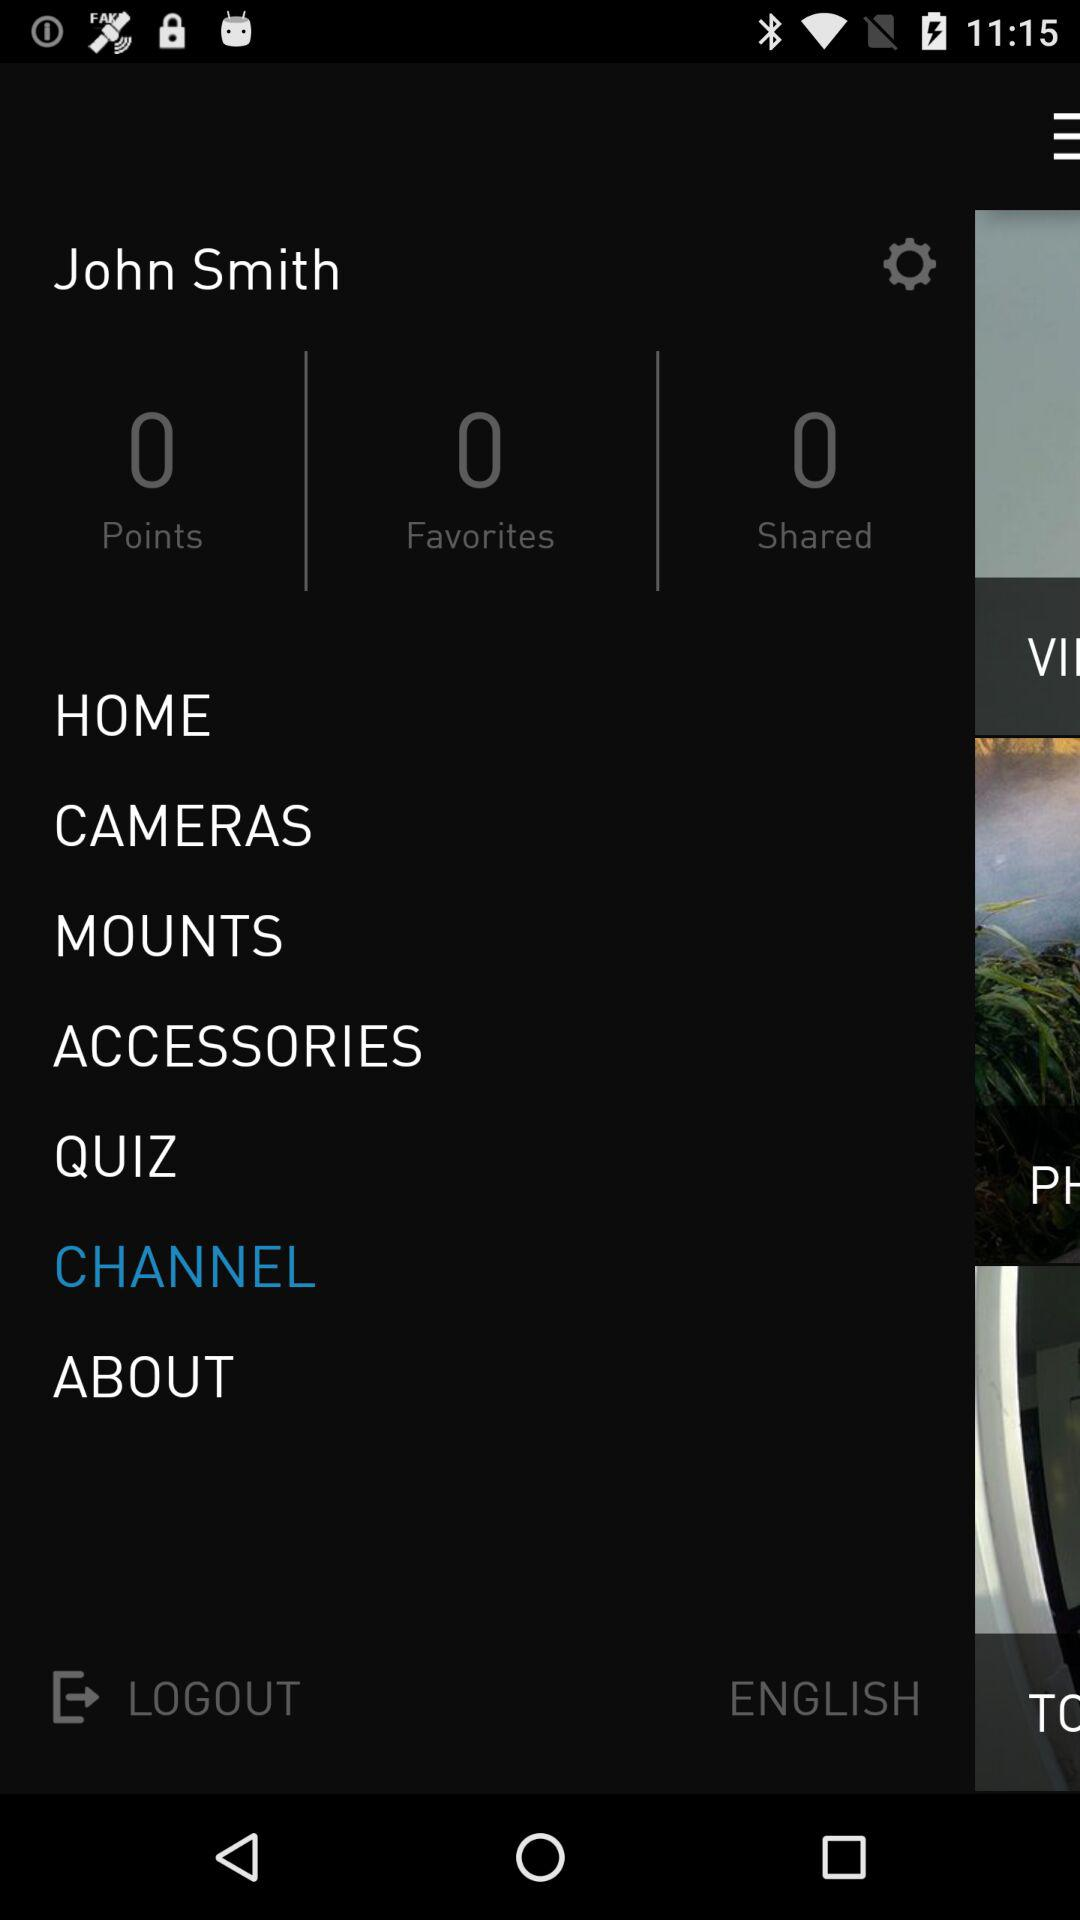What is the count of points? The count of points is 0. 